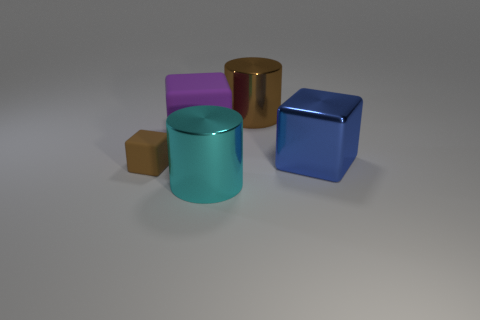What number of other things are the same size as the brown rubber cube? Upon reviewing the image, there appears to be no objects that are exactly the same size as the brown rubber cube, but the blue cube is closest in size, albeit slightly larger. 